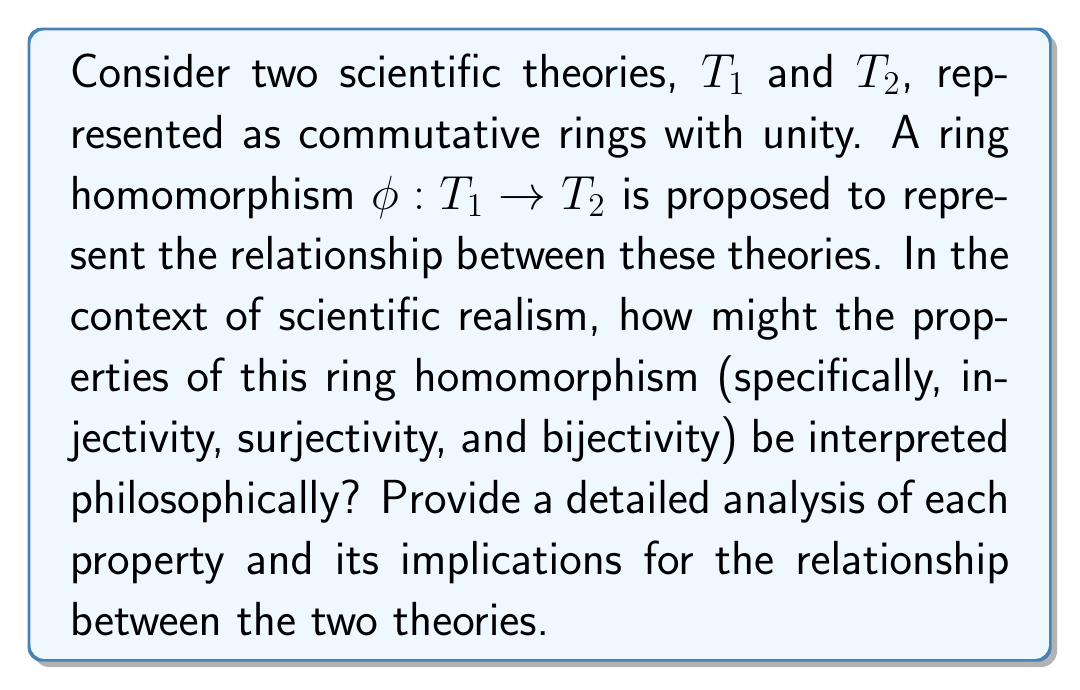What is the answer to this math problem? To analyze this question, we need to consider the properties of ring homomorphisms and their potential interpretations in the context of scientific theories:

1. Ring Homomorphism:
A function $\phi: T1 \rightarrow T2$ is a ring homomorphism if it preserves the ring operations:
   a) $\phi(a + b) = \phi(a) + \phi(b)$ for all $a, b \in T1$
   b) $\phi(ab) = \phi(a)\phi(b)$ for all $a, b \in T1$
   c) $\phi(1_{T1}) = 1_{T2}$

This preservation of structure can be interpreted as maintaining the logical and mathematical relationships between concepts in the two theories.

2. Injectivity:
A ring homomorphism $\phi$ is injective if $\phi(a) = \phi(b)$ implies $a = b$ for all $a, b \in T1$.

Philosophical interpretation: Injectivity suggests that T1 is at least as expressive as the part of T2 that it maps to. Each distinct element in T1 corresponds to a unique element in T2, implying that T1 doesn't lose any information when mapped to T2. This could be seen as T1 being a more fundamental or detailed theory, with T2 potentially being a higher-level or more abstract description.

3. Surjectivity:
A ring homomorphism $\phi$ is surjective if for every $y \in T2$, there exists an $x \in T1$ such that $\phi(x) = y$.

Philosophical interpretation: Surjectivity implies that T1 can account for all aspects of T2. Every concept or relationship in T2 has a corresponding element in T1. This could be interpreted as T1 being a more comprehensive theory that encompasses all aspects of T2, possibly serving as a unifying framework.

4. Bijectivity:
A ring homomorphism is bijective if it is both injective and surjective.

Philosophical interpretation: Bijectivity suggests a one-to-one correspondence between T1 and T2. This could be interpreted as the two theories being equivalent representations of the same underlying reality, differing perhaps only in their language or formalism. In the context of scientific realism, this might suggest that both theories are equally valid descriptions of the same phenomena.

5. Neither injective nor surjective:
If $\phi$ is neither injective nor surjective, it suggests a more complex relationship between T1 and T2.

Philosophical interpretation: This scenario could represent a partial mapping between theories, where some aspects of T1 correspond to T2, but neither theory fully encompasses or reduces to the other. This might be seen in cases where two theories overlap in some domains but diverge in others, or where one theory is an approximation of the other under certain conditions.
Answer: The properties of the ring homomorphism $\phi: T1 \rightarrow T2$ can be interpreted philosophically as follows:

1. Injectivity: T1 is at least as expressive as the mapped part of T2, potentially representing a more fundamental or detailed theory.
2. Surjectivity: T1 can account for all aspects of T2, possibly serving as a more comprehensive or unifying theory.
3. Bijectivity: T1 and T2 are equivalent representations of the same underlying reality, differing only in formalism.
4. Neither injective nor surjective: Represents a partial mapping or overlap between theories, potentially indicating approximation or domain-specific relationships.

These interpretations provide insights into the relationships between scientific theories in the context of scientific realism, reflecting the structural correspondences and potential reductions or unifications between different theoretical frameworks. 